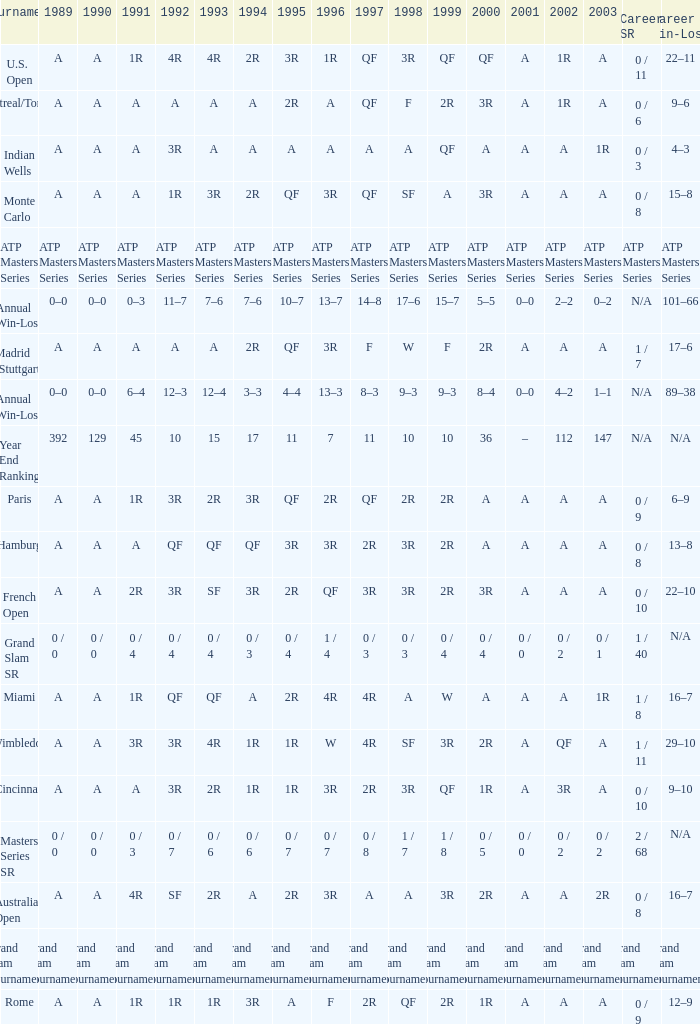What is the value in 1997 when the value in 1989 is A, 1995 is QF, 1996 is 3R and the career SR is 0 / 8? QF. 